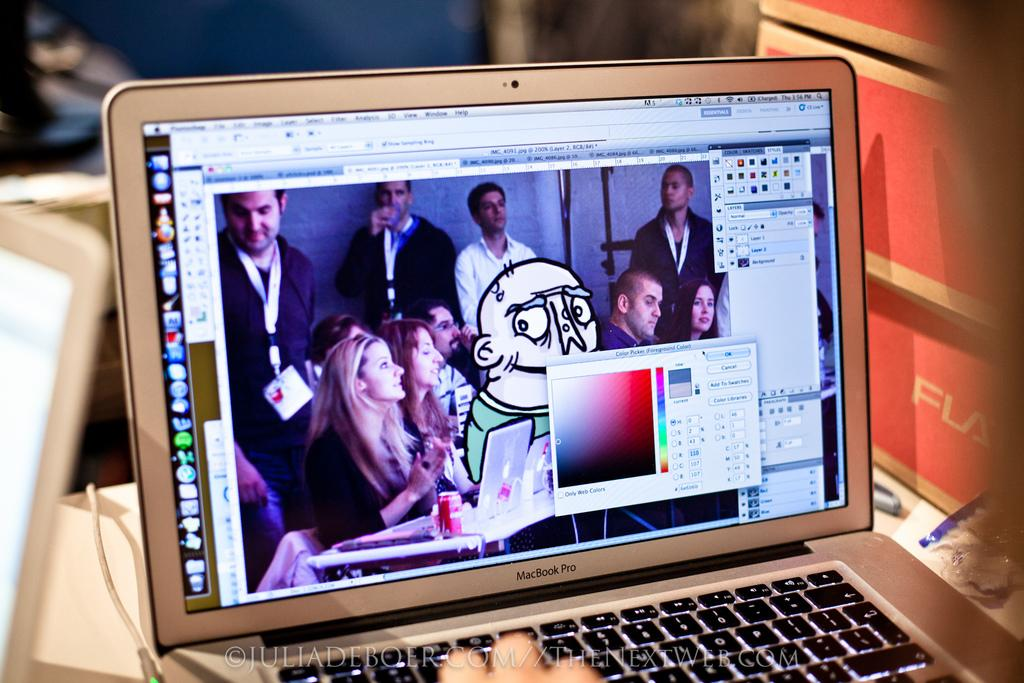Provide a one-sentence caption for the provided image. Someone is working on art graphics using a Macbook Pro. 